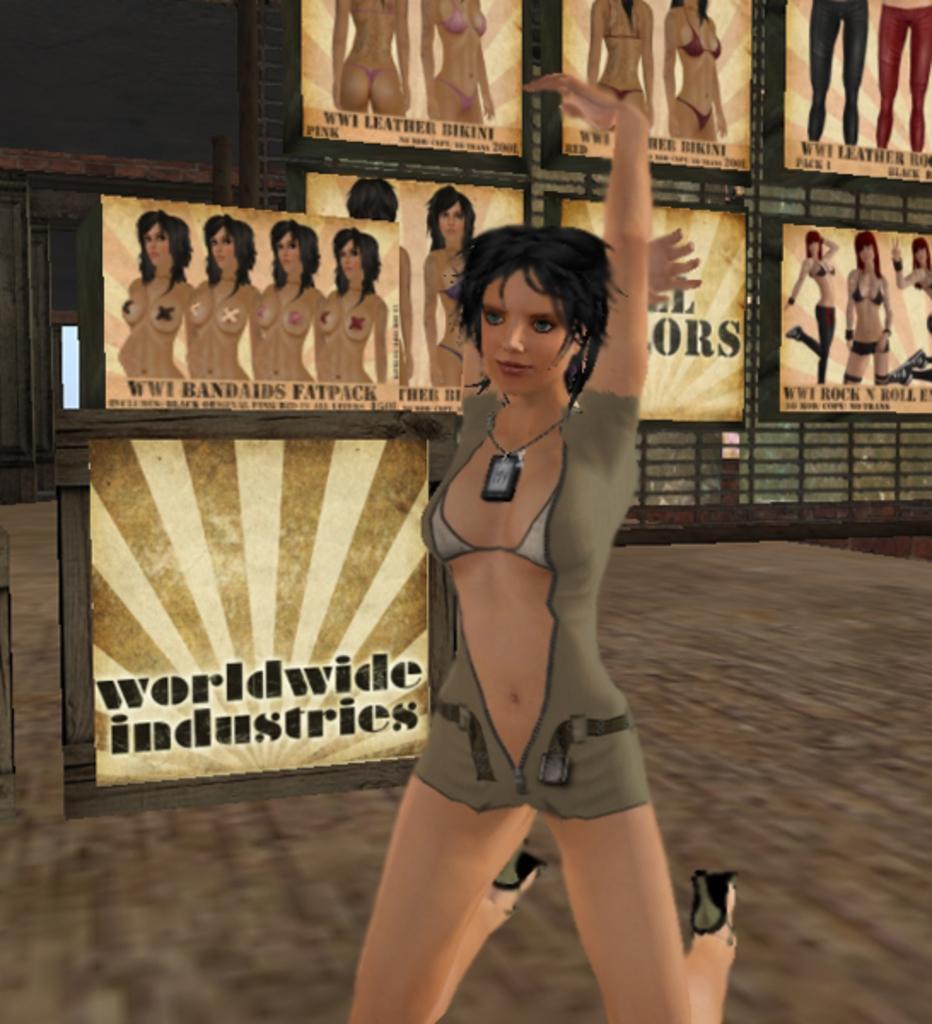Could you give a brief overview of what you see in this image? In this image, we can see depiction of a person. In the background, there are some posters. 